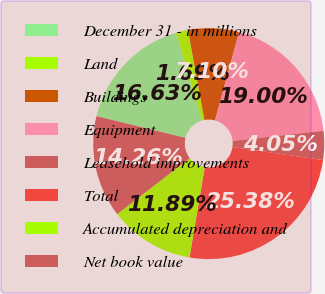Convert chart. <chart><loc_0><loc_0><loc_500><loc_500><pie_chart><fcel>December 31 - in millions<fcel>Land<fcel>Buildings<fcel>Equipment<fcel>Leasehold improvements<fcel>Total<fcel>Accumulated depreciation and<fcel>Net book value<nl><fcel>16.63%<fcel>1.69%<fcel>7.1%<fcel>19.0%<fcel>4.05%<fcel>25.38%<fcel>11.89%<fcel>14.26%<nl></chart> 